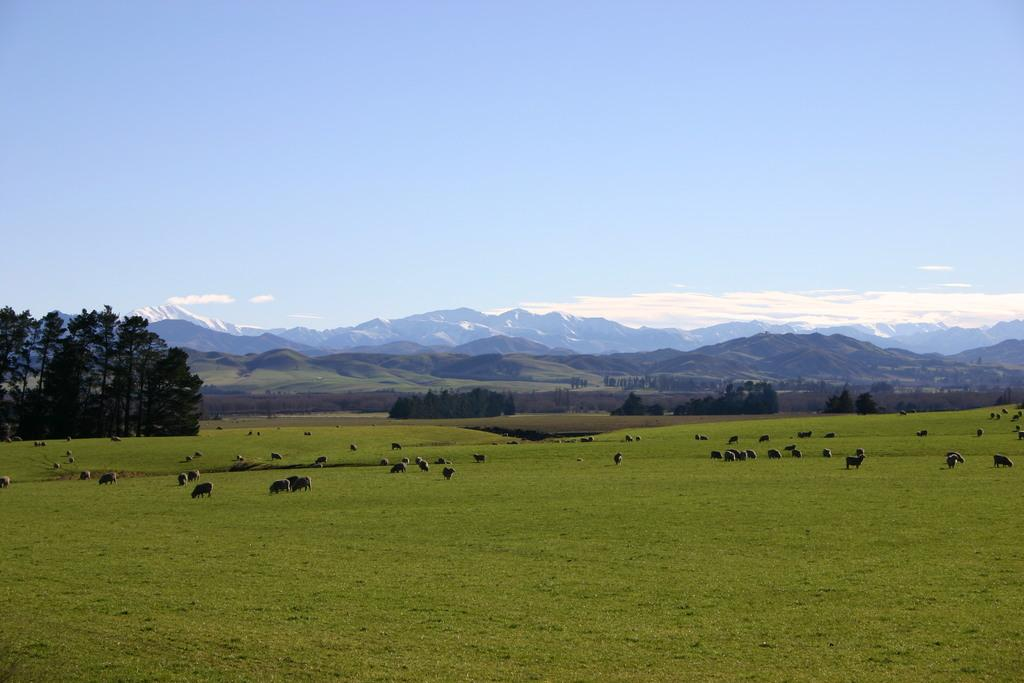What animals can be seen in the image? There is a herd of sheep grazing in the image. What type of vegetation is on the left side of the image? There are trees on the left side of the image. What can be seen in the background of the image? There are hills visible in the background of the image. Where is the nest of the vegetable in the image? There is no nest or vegetable present in the image. What type of vegetable is being crushed by the sheep in the image? There are no vegetables or crushing actions depicted in the image; the sheep are grazing peacefully. 